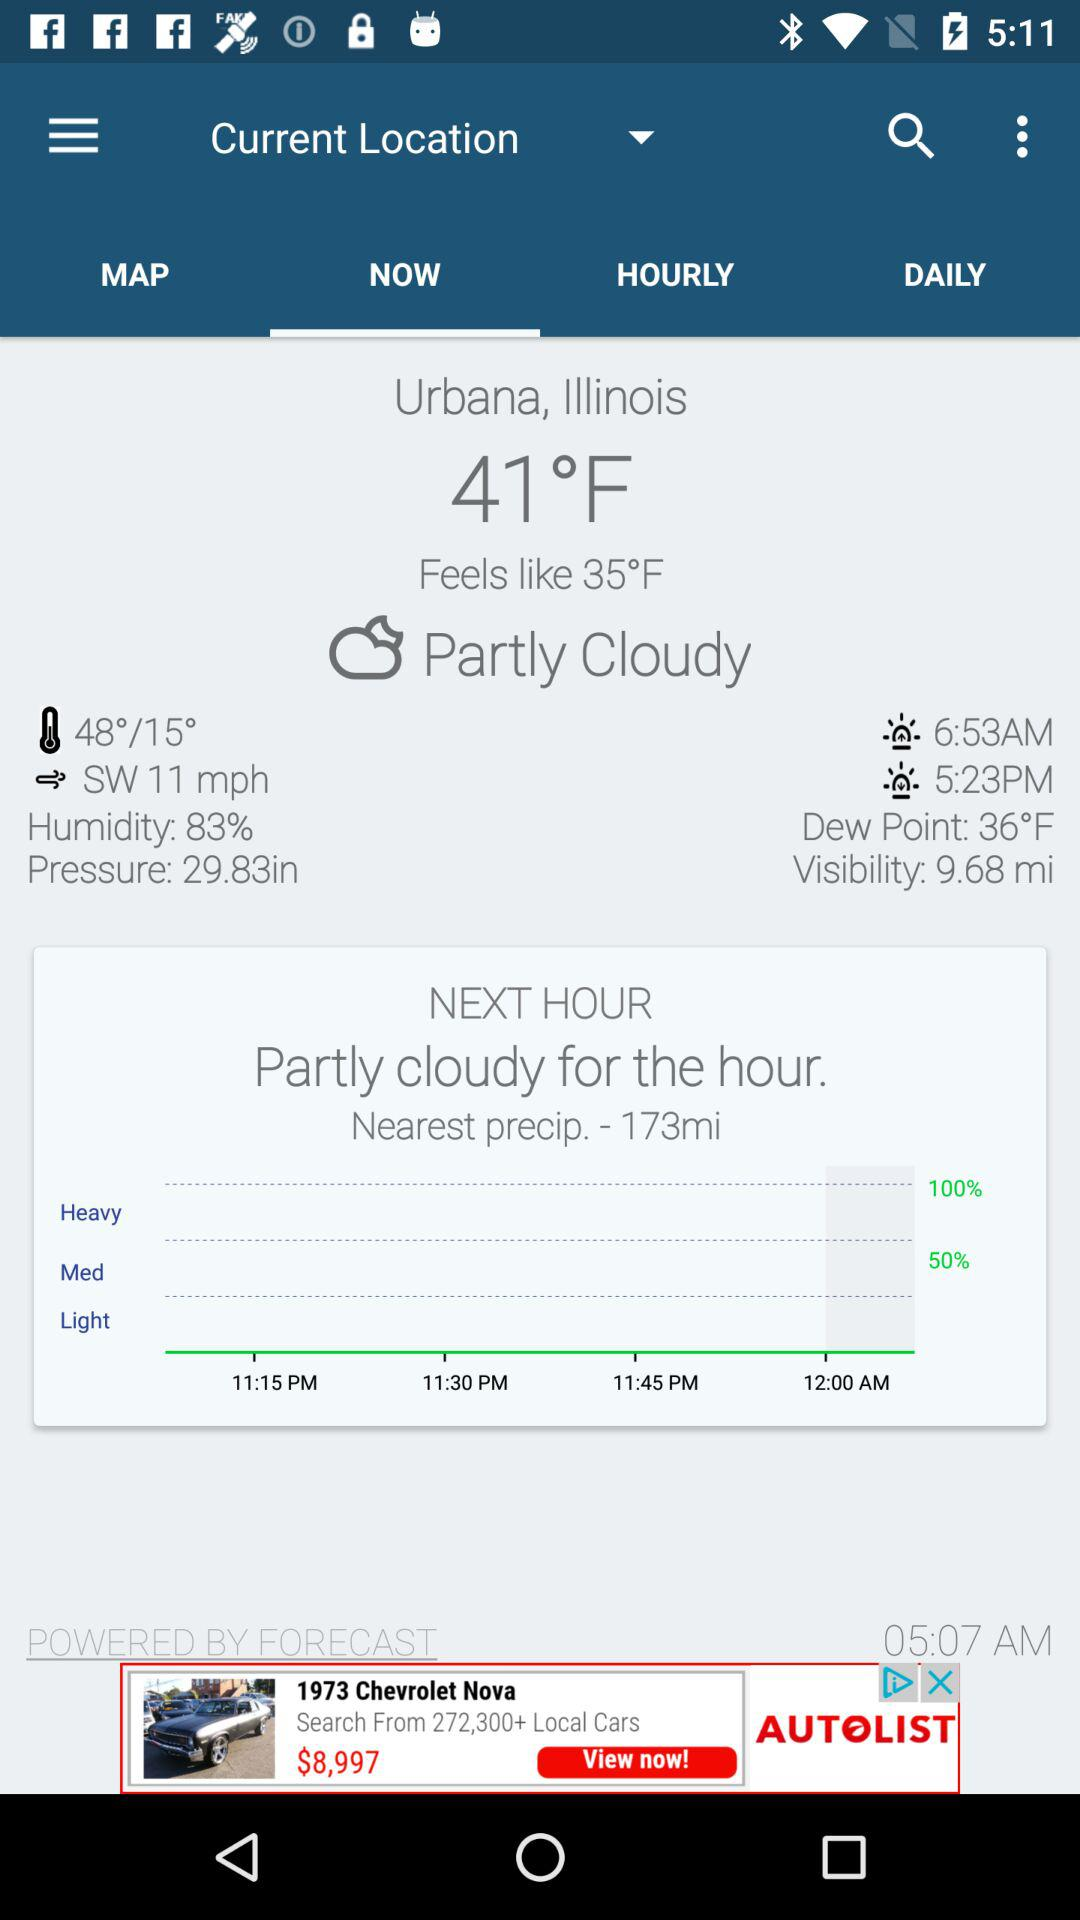How much is the dew point?
Answer the question using a single word or phrase. 36°F 